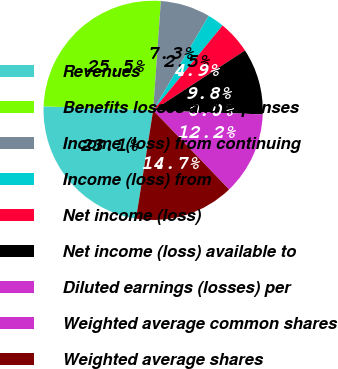<chart> <loc_0><loc_0><loc_500><loc_500><pie_chart><fcel>Revenues<fcel>Benefits losses and expenses<fcel>Income (loss) from continuing<fcel>Income (loss) from<fcel>Net income (loss)<fcel>Net income (loss) available to<fcel>Diluted earnings (losses) per<fcel>Weighted average common shares<fcel>Weighted average shares<nl><fcel>23.08%<fcel>25.53%<fcel>7.34%<fcel>2.45%<fcel>4.89%<fcel>9.79%<fcel>0.0%<fcel>12.23%<fcel>14.68%<nl></chart> 